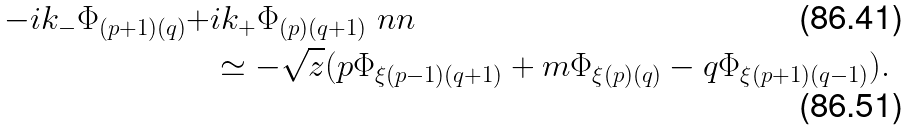Convert formula to latex. <formula><loc_0><loc_0><loc_500><loc_500>- i k _ { - } \Phi _ { ( p + 1 ) ( q ) } + & i k _ { + } \Phi _ { ( p ) ( q + 1 ) } \ n n \\ & \simeq - \sqrt { z } ( p \Phi _ { \xi ( p - 1 ) ( q + 1 ) } + m \Phi _ { \xi ( p ) ( q ) } - q \Phi _ { \xi ( p + 1 ) ( q - 1 ) } ) .</formula> 